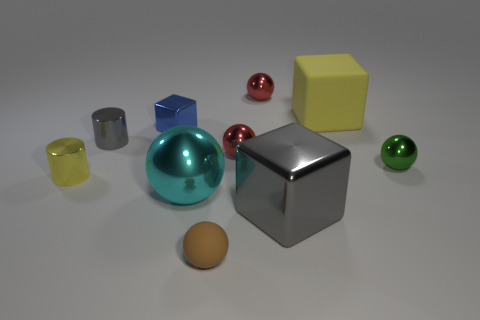There is a small cylinder that is the same color as the big rubber block; what is it made of?
Your response must be concise. Metal. Is there a metallic block that is behind the big thing on the left side of the tiny metallic ball that is behind the small cube?
Provide a succinct answer. Yes. Is the yellow thing to the left of the brown object made of the same material as the block that is behind the tiny blue metal cube?
Give a very brief answer. No. What number of objects are either yellow shiny objects or gray things that are on the right side of the blue cube?
Ensure brevity in your answer.  2. How many brown matte objects have the same shape as the green metallic object?
Provide a succinct answer. 1. There is a block that is the same size as the green ball; what is it made of?
Ensure brevity in your answer.  Metal. What size is the gray object behind the small object that is on the right side of the rubber object behind the green thing?
Provide a short and direct response. Small. Is the color of the rubber thing that is on the right side of the brown matte sphere the same as the shiny thing to the left of the gray cylinder?
Ensure brevity in your answer.  Yes. How many brown objects are tiny metallic spheres or metal cylinders?
Your answer should be compact. 0. How many gray metal blocks have the same size as the blue metallic thing?
Provide a short and direct response. 0. 